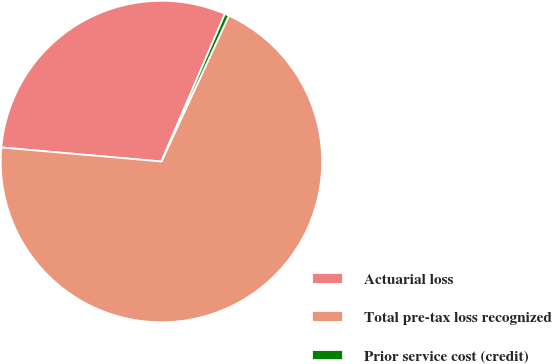Convert chart. <chart><loc_0><loc_0><loc_500><loc_500><pie_chart><fcel>Actuarial loss<fcel>Total pre-tax loss recognized<fcel>Prior service cost (credit)<nl><fcel>30.07%<fcel>69.5%<fcel>0.43%<nl></chart> 